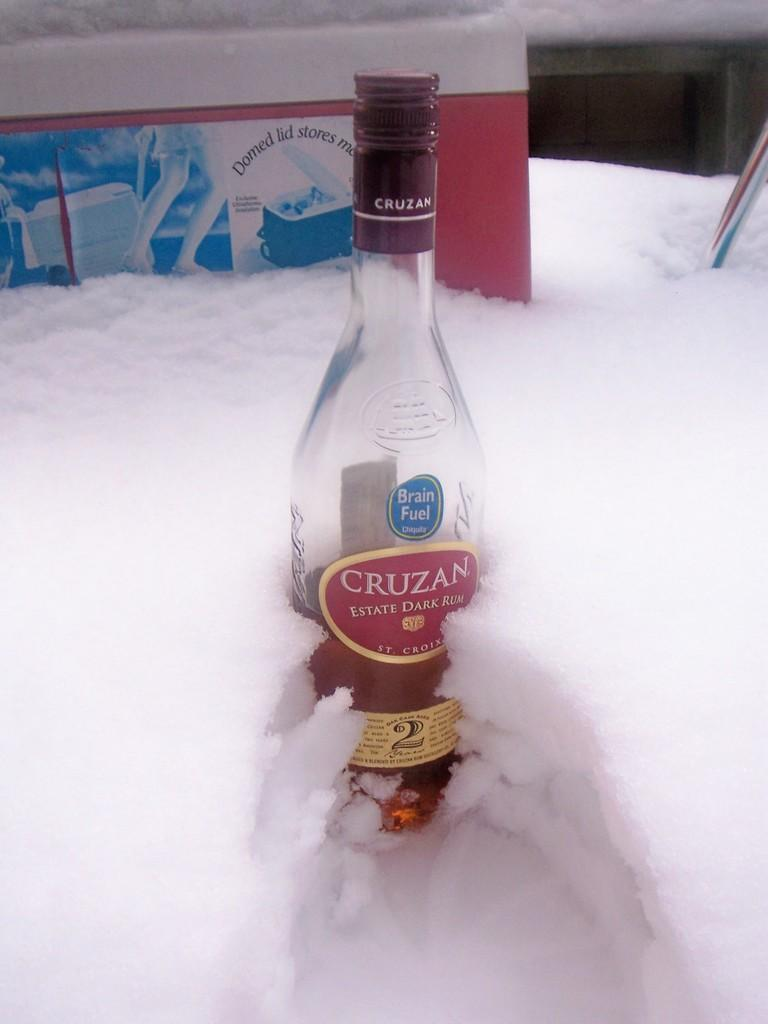<image>
Render a clear and concise summary of the photo. Cruzan dark rum bottle is sitting in the snow. 